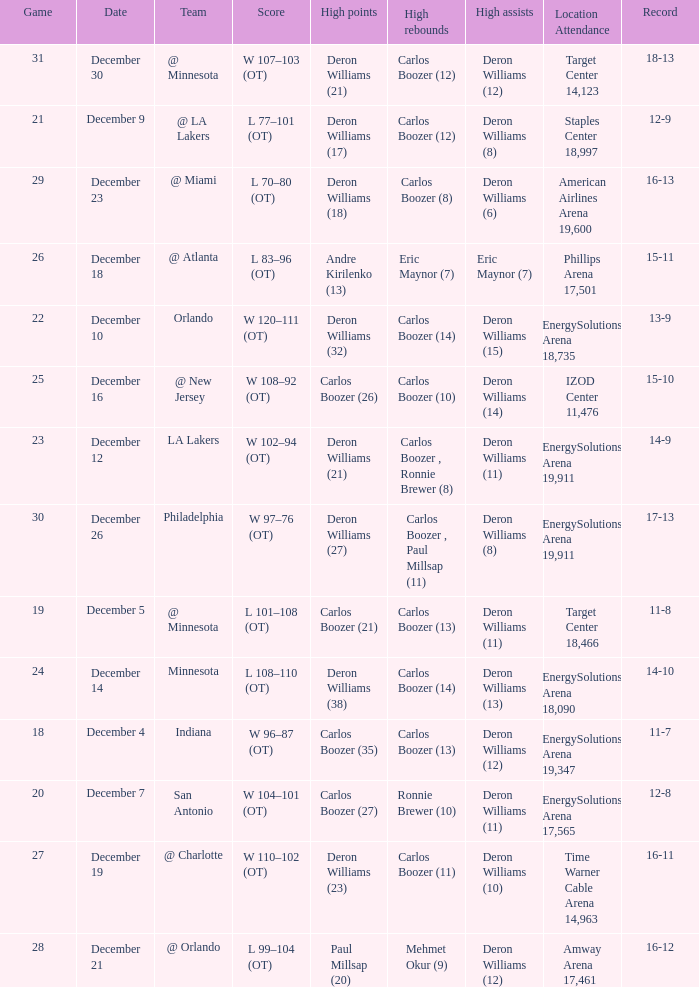Would you mind parsing the complete table? {'header': ['Game', 'Date', 'Team', 'Score', 'High points', 'High rebounds', 'High assists', 'Location Attendance', 'Record'], 'rows': [['31', 'December 30', '@ Minnesota', 'W 107–103 (OT)', 'Deron Williams (21)', 'Carlos Boozer (12)', 'Deron Williams (12)', 'Target Center 14,123', '18-13'], ['21', 'December 9', '@ LA Lakers', 'L 77–101 (OT)', 'Deron Williams (17)', 'Carlos Boozer (12)', 'Deron Williams (8)', 'Staples Center 18,997', '12-9'], ['29', 'December 23', '@ Miami', 'L 70–80 (OT)', 'Deron Williams (18)', 'Carlos Boozer (8)', 'Deron Williams (6)', 'American Airlines Arena 19,600', '16-13'], ['26', 'December 18', '@ Atlanta', 'L 83–96 (OT)', 'Andre Kirilenko (13)', 'Eric Maynor (7)', 'Eric Maynor (7)', 'Phillips Arena 17,501', '15-11'], ['22', 'December 10', 'Orlando', 'W 120–111 (OT)', 'Deron Williams (32)', 'Carlos Boozer (14)', 'Deron Williams (15)', 'EnergySolutions Arena 18,735', '13-9'], ['25', 'December 16', '@ New Jersey', 'W 108–92 (OT)', 'Carlos Boozer (26)', 'Carlos Boozer (10)', 'Deron Williams (14)', 'IZOD Center 11,476', '15-10'], ['23', 'December 12', 'LA Lakers', 'W 102–94 (OT)', 'Deron Williams (21)', 'Carlos Boozer , Ronnie Brewer (8)', 'Deron Williams (11)', 'EnergySolutions Arena 19,911', '14-9'], ['30', 'December 26', 'Philadelphia', 'W 97–76 (OT)', 'Deron Williams (27)', 'Carlos Boozer , Paul Millsap (11)', 'Deron Williams (8)', 'EnergySolutions Arena 19,911', '17-13'], ['19', 'December 5', '@ Minnesota', 'L 101–108 (OT)', 'Carlos Boozer (21)', 'Carlos Boozer (13)', 'Deron Williams (11)', 'Target Center 18,466', '11-8'], ['24', 'December 14', 'Minnesota', 'L 108–110 (OT)', 'Deron Williams (38)', 'Carlos Boozer (14)', 'Deron Williams (13)', 'EnergySolutions Arena 18,090', '14-10'], ['18', 'December 4', 'Indiana', 'W 96–87 (OT)', 'Carlos Boozer (35)', 'Carlos Boozer (13)', 'Deron Williams (12)', 'EnergySolutions Arena 19,347', '11-7'], ['20', 'December 7', 'San Antonio', 'W 104–101 (OT)', 'Carlos Boozer (27)', 'Ronnie Brewer (10)', 'Deron Williams (11)', 'EnergySolutions Arena 17,565', '12-8'], ['27', 'December 19', '@ Charlotte', 'W 110–102 (OT)', 'Deron Williams (23)', 'Carlos Boozer (11)', 'Deron Williams (10)', 'Time Warner Cable Arena 14,963', '16-11'], ['28', 'December 21', '@ Orlando', 'L 99–104 (OT)', 'Paul Millsap (20)', 'Mehmet Okur (9)', 'Deron Williams (12)', 'Amway Arena 17,461', '16-12']]} When was the game in which Deron Williams (13) did the high assists played? December 14. 